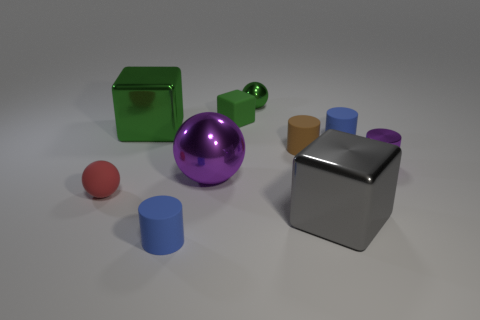Is there any other thing that has the same material as the tiny green cube?
Your answer should be very brief. Yes. Is the shape of the big purple thing the same as the green object behind the small cube?
Your response must be concise. Yes. There is another green thing that is the same shape as the small green matte thing; what is its size?
Your answer should be very brief. Large. Is the color of the tiny metallic object that is in front of the small brown cylinder the same as the metal ball in front of the large green thing?
Offer a very short reply. Yes. What number of other objects are there of the same color as the large metallic ball?
Provide a succinct answer. 1. Is the size of the blue cylinder in front of the brown thing the same as the large purple metallic thing?
Provide a succinct answer. No. Are there any purple spheres that have the same size as the green rubber block?
Offer a very short reply. No. What is the color of the tiny rubber object that is in front of the gray block?
Offer a terse response. Blue. What is the shape of the large object that is in front of the purple shiny cylinder and behind the red ball?
Provide a short and direct response. Sphere. What number of tiny blue matte things have the same shape as the small red object?
Provide a short and direct response. 0. 